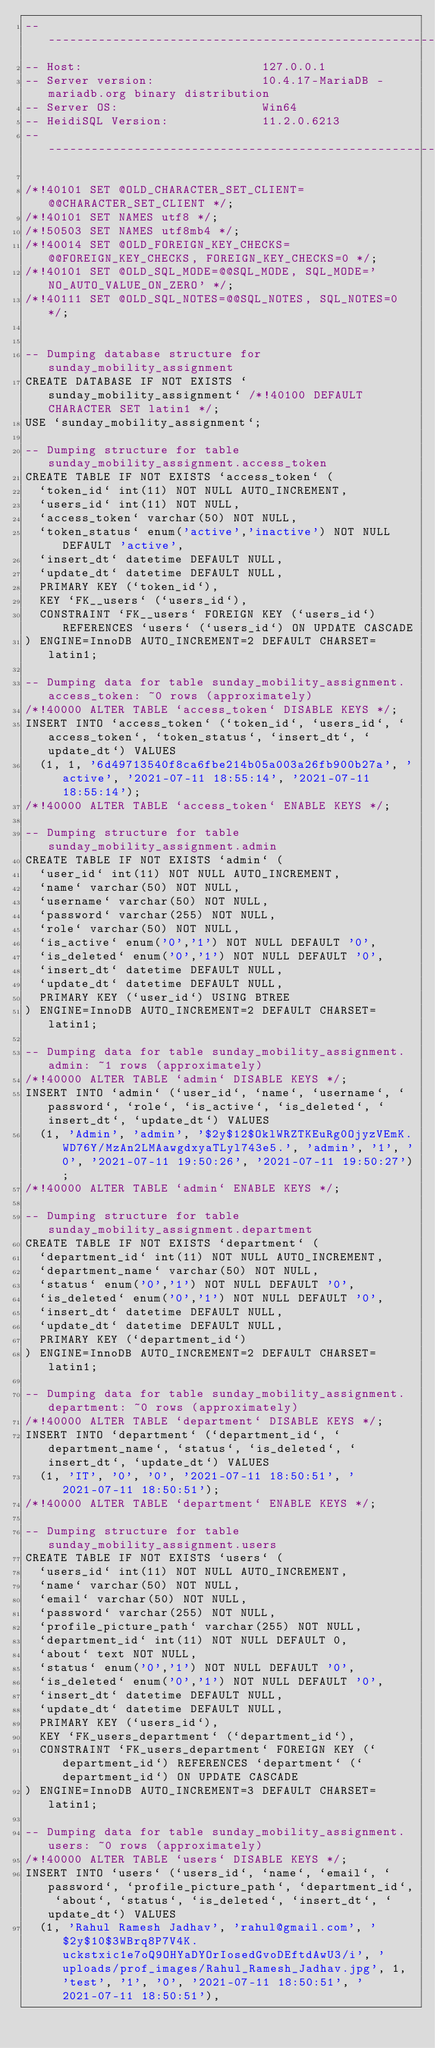<code> <loc_0><loc_0><loc_500><loc_500><_SQL_>-- --------------------------------------------------------
-- Host:                         127.0.0.1
-- Server version:               10.4.17-MariaDB - mariadb.org binary distribution
-- Server OS:                    Win64
-- HeidiSQL Version:             11.2.0.6213
-- --------------------------------------------------------

/*!40101 SET @OLD_CHARACTER_SET_CLIENT=@@CHARACTER_SET_CLIENT */;
/*!40101 SET NAMES utf8 */;
/*!50503 SET NAMES utf8mb4 */;
/*!40014 SET @OLD_FOREIGN_KEY_CHECKS=@@FOREIGN_KEY_CHECKS, FOREIGN_KEY_CHECKS=0 */;
/*!40101 SET @OLD_SQL_MODE=@@SQL_MODE, SQL_MODE='NO_AUTO_VALUE_ON_ZERO' */;
/*!40111 SET @OLD_SQL_NOTES=@@SQL_NOTES, SQL_NOTES=0 */;


-- Dumping database structure for sunday_mobility_assignment
CREATE DATABASE IF NOT EXISTS `sunday_mobility_assignment` /*!40100 DEFAULT CHARACTER SET latin1 */;
USE `sunday_mobility_assignment`;

-- Dumping structure for table sunday_mobility_assignment.access_token
CREATE TABLE IF NOT EXISTS `access_token` (
  `token_id` int(11) NOT NULL AUTO_INCREMENT,
  `users_id` int(11) NOT NULL,
  `access_token` varchar(50) NOT NULL,
  `token_status` enum('active','inactive') NOT NULL DEFAULT 'active',
  `insert_dt` datetime DEFAULT NULL,
  `update_dt` datetime DEFAULT NULL,
  PRIMARY KEY (`token_id`),
  KEY `FK__users` (`users_id`),
  CONSTRAINT `FK__users` FOREIGN KEY (`users_id`) REFERENCES `users` (`users_id`) ON UPDATE CASCADE
) ENGINE=InnoDB AUTO_INCREMENT=2 DEFAULT CHARSET=latin1;

-- Dumping data for table sunday_mobility_assignment.access_token: ~0 rows (approximately)
/*!40000 ALTER TABLE `access_token` DISABLE KEYS */;
INSERT INTO `access_token` (`token_id`, `users_id`, `access_token`, `token_status`, `insert_dt`, `update_dt`) VALUES
	(1, 1, '6d49713540f8ca6fbe214b05a003a26fb900b27a', 'active', '2021-07-11 18:55:14', '2021-07-11 18:55:14');
/*!40000 ALTER TABLE `access_token` ENABLE KEYS */;

-- Dumping structure for table sunday_mobility_assignment.admin
CREATE TABLE IF NOT EXISTS `admin` (
  `user_id` int(11) NOT NULL AUTO_INCREMENT,
  `name` varchar(50) NOT NULL,
  `username` varchar(50) NOT NULL,
  `password` varchar(255) NOT NULL,
  `role` varchar(50) NOT NULL,
  `is_active` enum('0','1') NOT NULL DEFAULT '0',
  `is_deleted` enum('0','1') NOT NULL DEFAULT '0',
  `insert_dt` datetime DEFAULT NULL,
  `update_dt` datetime DEFAULT NULL,
  PRIMARY KEY (`user_id`) USING BTREE
) ENGINE=InnoDB AUTO_INCREMENT=2 DEFAULT CHARSET=latin1;

-- Dumping data for table sunday_mobility_assignment.admin: ~1 rows (approximately)
/*!40000 ALTER TABLE `admin` DISABLE KEYS */;
INSERT INTO `admin` (`user_id`, `name`, `username`, `password`, `role`, `is_active`, `is_deleted`, `insert_dt`, `update_dt`) VALUES
	(1, 'Admin', 'admin', '$2y$12$OklWRZTKEuRg0OjyzVEmK.WD76Y/MzAn2LMAawgdxyaTLyl743e5.', 'admin', '1', '0', '2021-07-11 19:50:26', '2021-07-11 19:50:27');
/*!40000 ALTER TABLE `admin` ENABLE KEYS */;

-- Dumping structure for table sunday_mobility_assignment.department
CREATE TABLE IF NOT EXISTS `department` (
  `department_id` int(11) NOT NULL AUTO_INCREMENT,
  `department_name` varchar(50) NOT NULL,
  `status` enum('0','1') NOT NULL DEFAULT '0',
  `is_deleted` enum('0','1') NOT NULL DEFAULT '0',
  `insert_dt` datetime DEFAULT NULL,
  `update_dt` datetime DEFAULT NULL,
  PRIMARY KEY (`department_id`)
) ENGINE=InnoDB AUTO_INCREMENT=2 DEFAULT CHARSET=latin1;

-- Dumping data for table sunday_mobility_assignment.department: ~0 rows (approximately)
/*!40000 ALTER TABLE `department` DISABLE KEYS */;
INSERT INTO `department` (`department_id`, `department_name`, `status`, `is_deleted`, `insert_dt`, `update_dt`) VALUES
	(1, 'IT', '0', '0', '2021-07-11 18:50:51', '2021-07-11 18:50:51');
/*!40000 ALTER TABLE `department` ENABLE KEYS */;

-- Dumping structure for table sunday_mobility_assignment.users
CREATE TABLE IF NOT EXISTS `users` (
  `users_id` int(11) NOT NULL AUTO_INCREMENT,
  `name` varchar(50) NOT NULL,
  `email` varchar(50) NOT NULL,
  `password` varchar(255) NOT NULL,
  `profile_picture_path` varchar(255) NOT NULL,
  `department_id` int(11) NOT NULL DEFAULT 0,
  `about` text NOT NULL,
  `status` enum('0','1') NOT NULL DEFAULT '0',
  `is_deleted` enum('0','1') NOT NULL DEFAULT '0',
  `insert_dt` datetime DEFAULT NULL,
  `update_dt` datetime DEFAULT NULL,
  PRIMARY KEY (`users_id`),
  KEY `FK_users_department` (`department_id`),
  CONSTRAINT `FK_users_department` FOREIGN KEY (`department_id`) REFERENCES `department` (`department_id`) ON UPDATE CASCADE
) ENGINE=InnoDB AUTO_INCREMENT=3 DEFAULT CHARSET=latin1;

-- Dumping data for table sunday_mobility_assignment.users: ~0 rows (approximately)
/*!40000 ALTER TABLE `users` DISABLE KEYS */;
INSERT INTO `users` (`users_id`, `name`, `email`, `password`, `profile_picture_path`, `department_id`, `about`, `status`, `is_deleted`, `insert_dt`, `update_dt`) VALUES
	(1, 'Rahul Ramesh Jadhav', 'rahul@gmail.com', '$2y$10$3WBrq8P7V4K.uckstxic1e7oQ9OHYaDYOrIosedGvoDEftdAwU3/i', 'uploads/prof_images/Rahul_Ramesh_Jadhav.jpg', 1, 'test', '1', '0', '2021-07-11 18:50:51', '2021-07-11 18:50:51'),</code> 